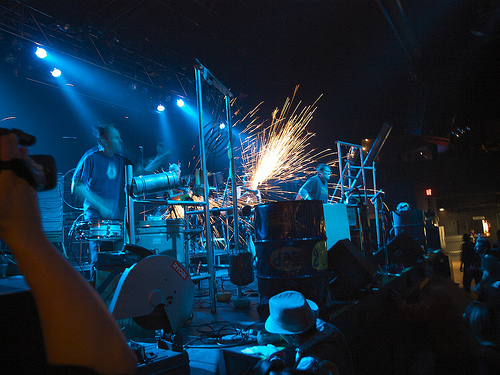<image>
Can you confirm if the man is in front of the sparks? Yes. The man is positioned in front of the sparks, appearing closer to the camera viewpoint. 